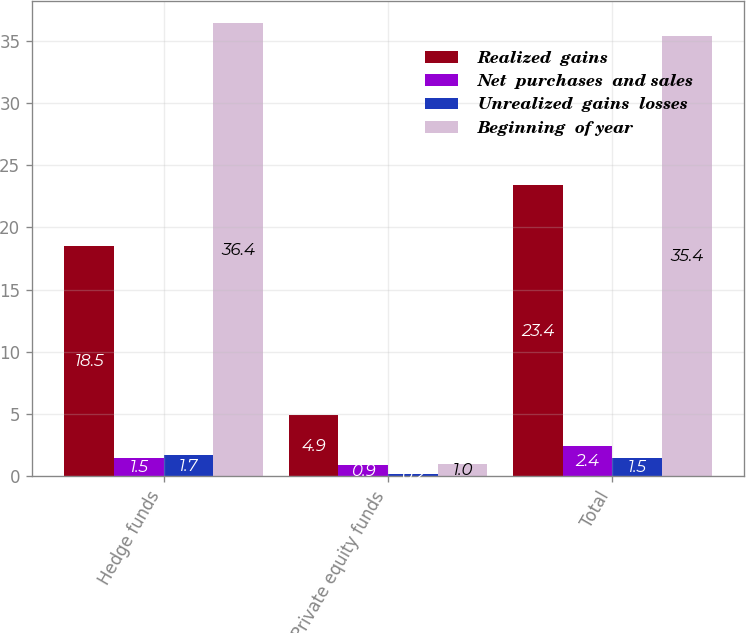Convert chart. <chart><loc_0><loc_0><loc_500><loc_500><stacked_bar_chart><ecel><fcel>Hedge funds<fcel>Private equity funds<fcel>Total<nl><fcel>Realized  gains<fcel>18.5<fcel>4.9<fcel>23.4<nl><fcel>Net  purchases  and sales<fcel>1.5<fcel>0.9<fcel>2.4<nl><fcel>Unrealized  gains  losses<fcel>1.7<fcel>0.2<fcel>1.5<nl><fcel>Beginning  of year<fcel>36.4<fcel>1<fcel>35.4<nl></chart> 